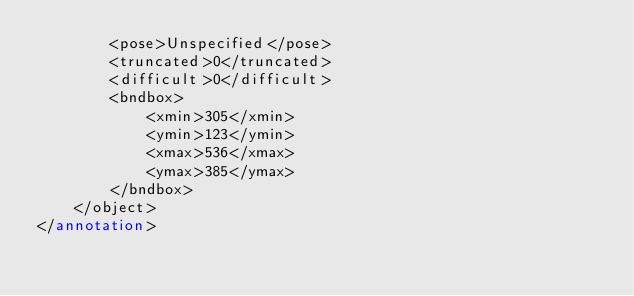Convert code to text. <code><loc_0><loc_0><loc_500><loc_500><_XML_>		<pose>Unspecified</pose>
		<truncated>0</truncated>
		<difficult>0</difficult>
		<bndbox>
			<xmin>305</xmin>
			<ymin>123</ymin>
			<xmax>536</xmax>
			<ymax>385</ymax>
		</bndbox>
	</object>
</annotation>
</code> 